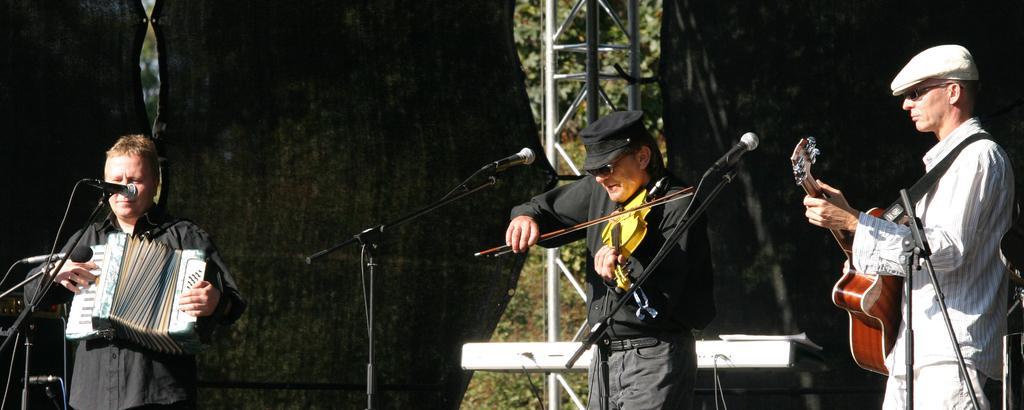Describe this image in one or two sentences. Left side of the image there is a person holding a musical instrument. Before him there are few mike stands. Middle of the image there is a person holding a violin. He is wearing goggles and cap. Right side there is a person holding a guitar. He is wearing goggles and cap. Middle of the image there are few metal rods. On both sides of it curtains are attached to it. Behind there are few plants and trees on the grassland. 